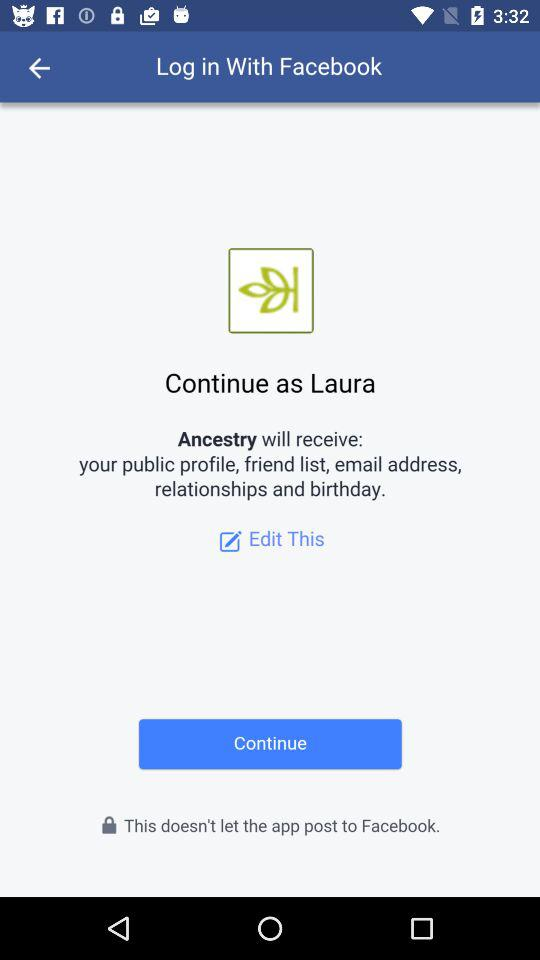What application is asking for permission? The application asking for permission is "Ancestry". 